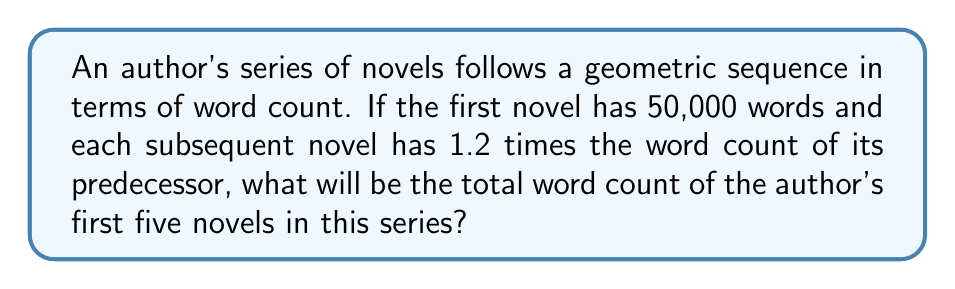What is the answer to this math problem? Let's approach this step-by-step:

1) First, we need to identify the geometric sequence. We're given:
   - First term, $a = 50,000$
   - Common ratio, $r = 1.2$

2) The word counts for each novel will be:
   - 1st novel: $50,000$
   - 2nd novel: $50,000 \times 1.2 = 60,000$
   - 3rd novel: $60,000 \times 1.2 = 72,000$
   - 4th novel: $72,000 \times 1.2 = 86,400$
   - 5th novel: $86,400 \times 1.2 = 103,680$

3) To find the total, we need to sum these terms. We can use the formula for the sum of a geometric series:

   $$S_n = \frac{a(1-r^n)}{1-r}$$

   Where:
   $S_n$ is the sum of the first $n$ terms
   $a$ is the first term
   $r$ is the common ratio
   $n$ is the number of terms

4) Plugging in our values:

   $$S_5 = \frac{50,000(1-1.2^5)}{1-1.2}$$

5) Simplify:
   $$S_5 = \frac{50,000(1-2.48832)}{-0.2}$$
   $$S_5 = \frac{50,000(-1.48832)}{-0.2}$$
   $$S_5 = 372,080$$

Therefore, the total word count of the first five novels is 372,080 words.
Answer: 372,080 words 